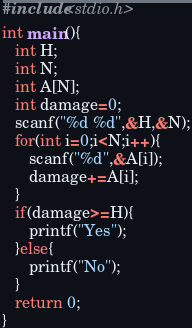<code> <loc_0><loc_0><loc_500><loc_500><_C_>#include<stdio.h>
int main(){
   int H;
   int N;
   int A[N];
   int damage=0;
   scanf("%d %d",&H,&N);
   for(int i=0;i<N;i++){
      scanf("%d",&A[i]);
      damage+=A[i];
   }
   if(damage>=H){
      printf("Yes");
   }else{
      printf("No");
   }
   return 0;
}
</code> 